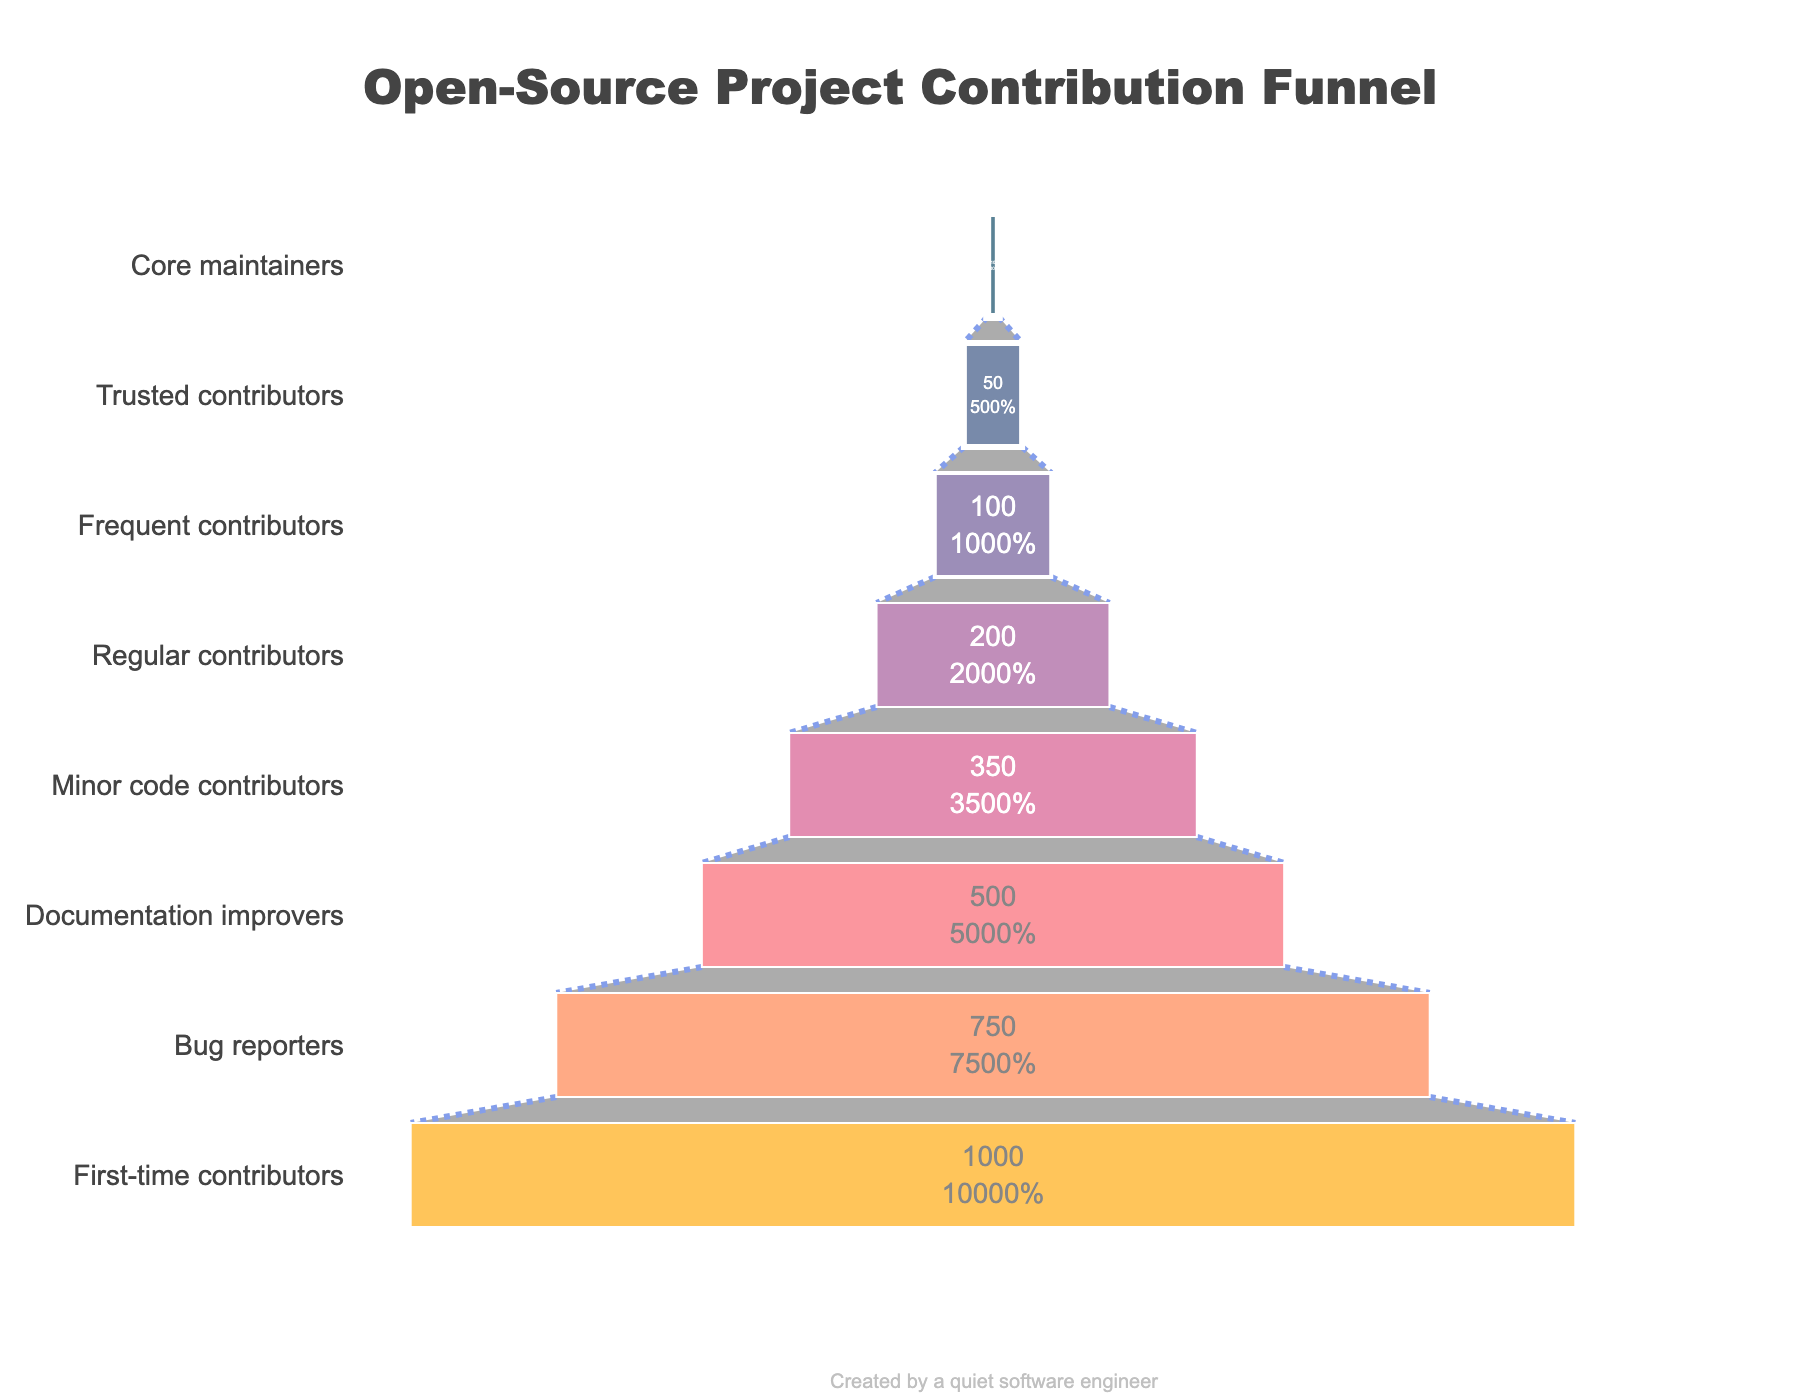Who has greater contributors, bug reporters or minor code contributors? Bug reporters have 750 contributors and minor code contributors have 350. By comparing these two numbers, we see that bug reporters have a greater number of contributors.
Answer: Bug reporters What's the difference in the number of contributors between first-time contributors and core maintainers? First-time contributors have 1000 contributors, and core maintainers have 10. The difference is calculated by subtracting the number of core maintainers from first-time contributors, which is 1000 - 10.
Answer: 990 Which stage of contributors represents the smallest group? The stage with the smallest number of contributors is the one with the lowest value. Core maintainers have the smallest number with 10 contributors.
Answer: Core maintainers How many stages are displayed in the funnel chart? Counting each unique stage listed in the funnel chart, we can see that there are 8 stages.
Answer: 8 What percentage of initial contributors become regular contributors? Regular contributors have 200 members out of the initial 1000 first-time contributors. To find the percentage, divide 200 by 1000 and multiply by 100, giving us (200/1000) * 100.
Answer: 20% What is the combined number of frequent and trusted contributors? Frequent contributors are 100 and trusted contributors are 50. Adding these together, 100 + 50 = 150.
Answer: 150 Is the number of documentation improvers greater than the sum of frequent and trusted contributors? Documentation improvers have 500 contributors. The sum of frequent and trusted contributors is 100 + 50 = 150. Since 500 is greater than 150, the answer is yes.
Answer: Yes How many unique color shades are used in the funnel chart? Each stage in the funnel chart is represented by a unique color. Counting the distinct colors listed, there are 8 unique shades.
Answer: 8 